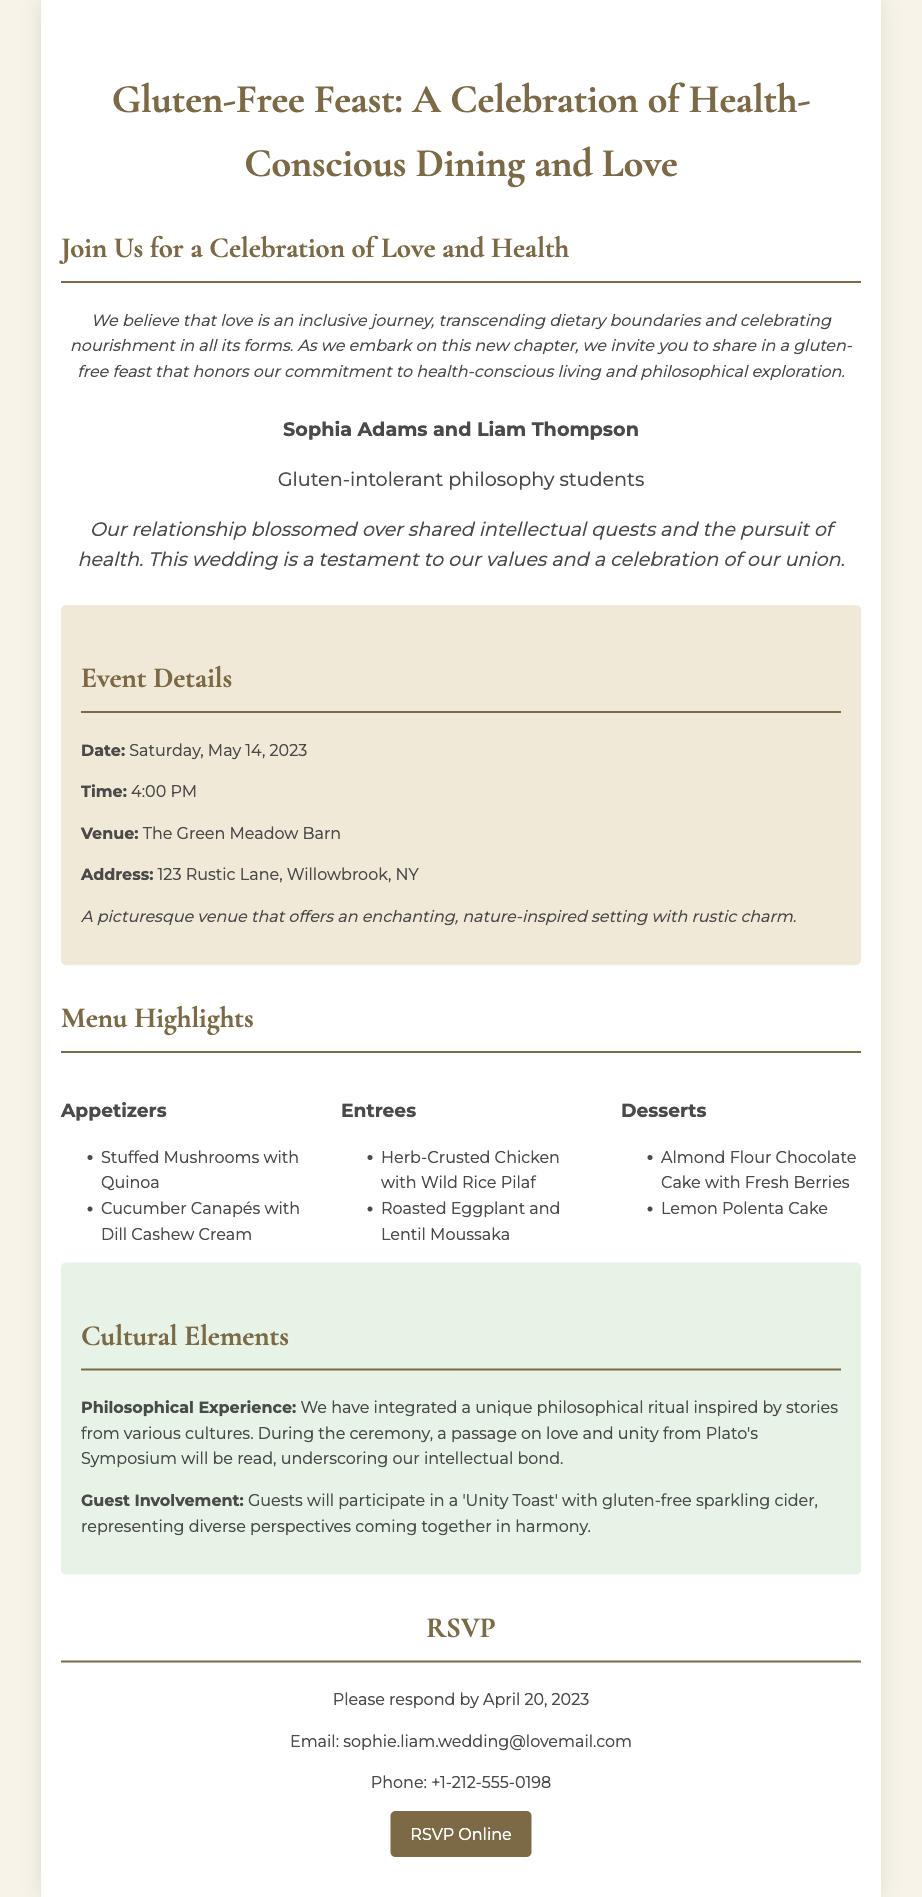What is the wedding date? The wedding date is mentioned in the event details section of the document.
Answer: Saturday, May 14, 2023 Who are the hosts of the wedding? The hosts are introduced at the top of the document, stating their names and a brief description.
Answer: Sophia Adams and Liam Thompson What type of venue is The Green Meadow Barn? The venue description gives insight into its atmosphere and style.
Answer: A picturesque venue that offers an enchanting, nature-inspired setting with rustic charm What type of cake is served for dessert? The dessert section lists specific items, including a cake.
Answer: Almond Flour Chocolate Cake with Fresh Berries What philosophical text is referenced in the ceremony? The cultural elements define the philosophical experience, mentioning the text being read.
Answer: Plato's Symposium What will guests toast with? Guest involvement describes the drink for the toast during the event.
Answer: Gluten-free sparkling cider When is the RSVP deadline? The RSVP section specifies the date by which guests should respond.
Answer: April 20, 2023 What kind of dining does the wedding celebrate? The intro paragraph highlights the emphasis of the wedding feast.
Answer: Health-Conscious Dining What is the theme of the wedding? The wedding's title and introductory message convey its core theme.
Answer: Gluten-Free Feast 